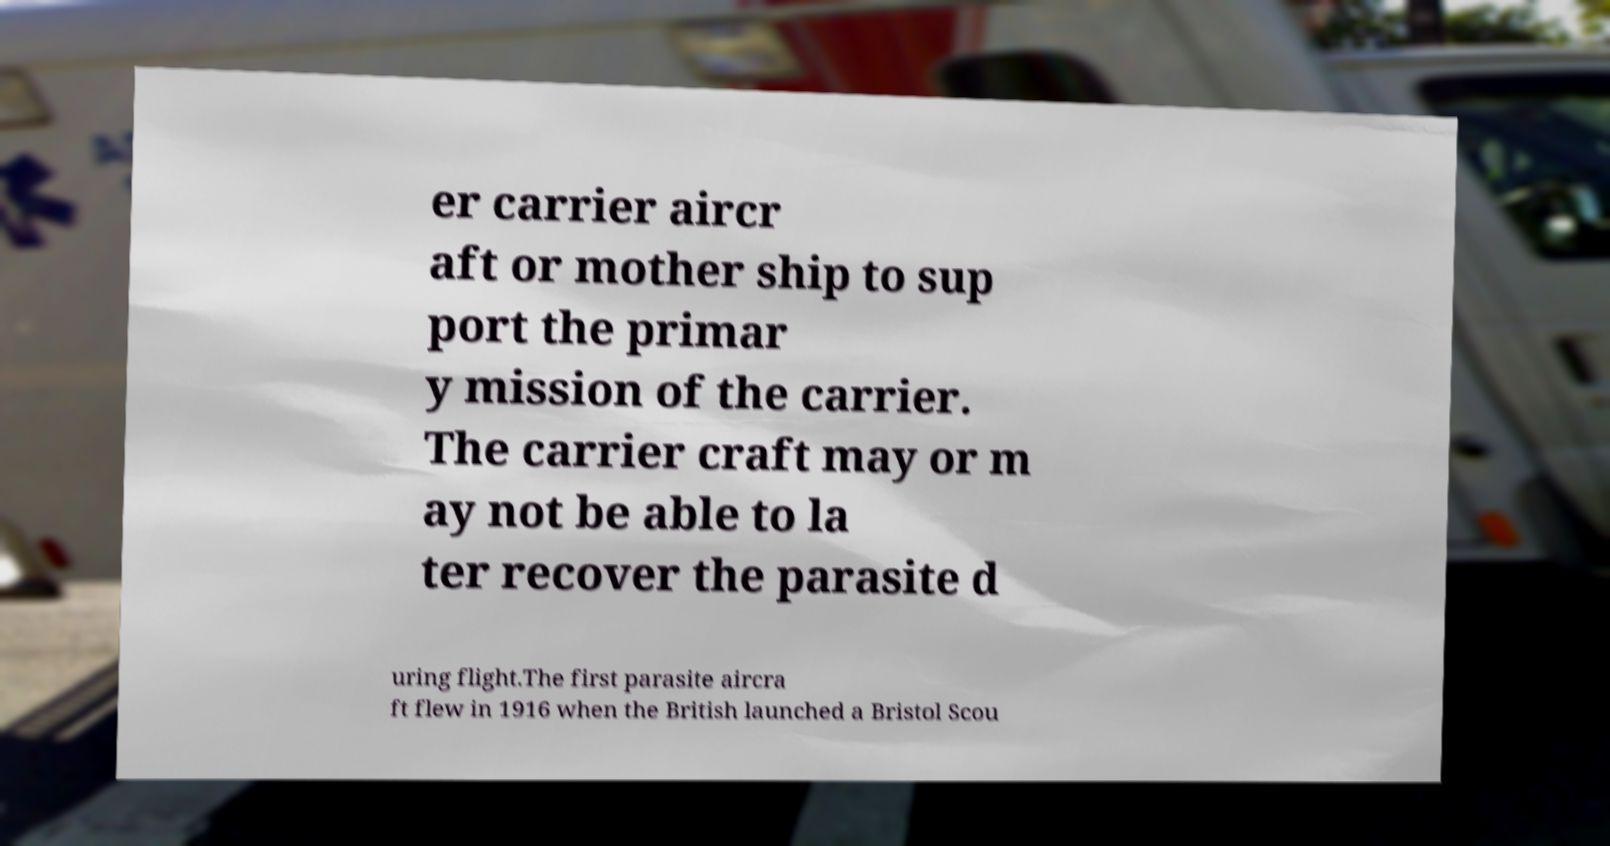There's text embedded in this image that I need extracted. Can you transcribe it verbatim? er carrier aircr aft or mother ship to sup port the primar y mission of the carrier. The carrier craft may or m ay not be able to la ter recover the parasite d uring flight.The first parasite aircra ft flew in 1916 when the British launched a Bristol Scou 